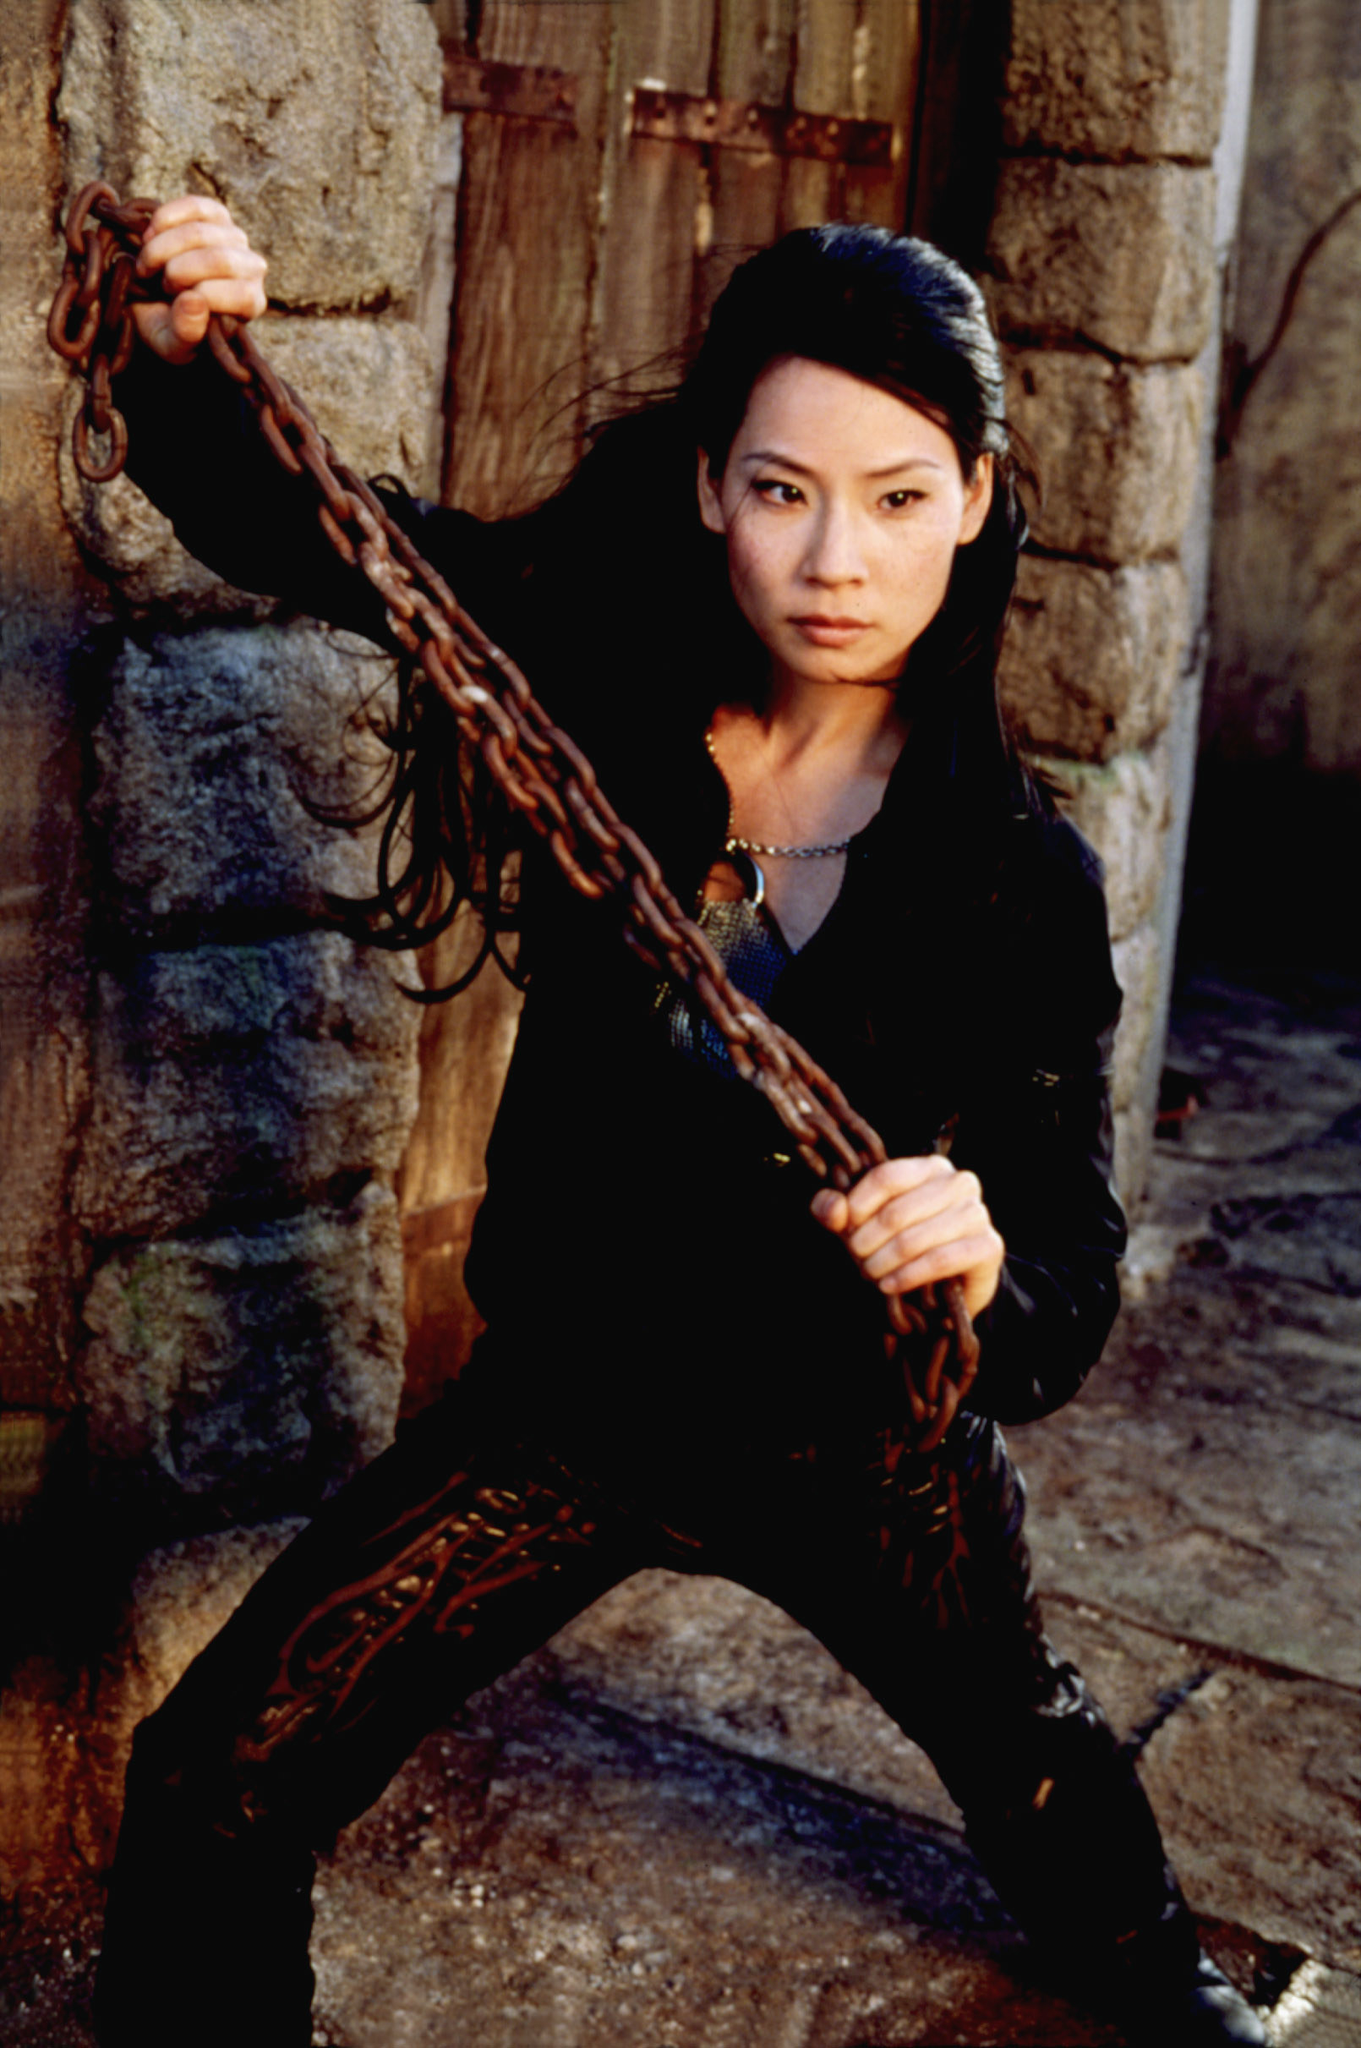How might this scene play out if it were part of a theatrical performance? If this scene were part of a theatrical performance, it would likely be a dramatic and tense moment. The character would emerge from the shadows, gripping the chain, with a spotlight highlighting her intense expression and stance. The set would be designed to reflect the aged stone walls and wooden door, adding to the historical and foreboding atmosphere. The lighting would be moody, with flickering torches or dim, focused beams enhancing the tension. As she prepares for a confrontation, the sound of distant, ominous music would fill the theater, building suspense. Her movements would be deliberate and powerful, maintaining the audience's focus and anticipation. Dialogue might be sparse, relying heavily on her body language and the ambient sounds to convey the significance of the moment. What roles would lighting and sound play in highlighting this scene? In this theatrical scene, lighting and sound are crucial elements. The lighting would be strategically designed to cast stark shadows, emphasizing the character's determined pose and creating a sense of impending danger. Spotlights might highlight her facial expressions, adding depth to her emotions. Dim, ambient light would cast a gloomy atmosphere over the stone walls and wooden door, enhancing the setting's sense of age and foreboding. Sound effects would include the subtle clinking of the chain, the echo of footsteps on the stone floor, and the creak of the wooden door. Underlying music might be minimalistic yet intense, using deep, resonant tones to build tension. Together, these elements draw the audience into the moment, heightening the drama and setting the tone for the unfolding story. Describe her backstory leading up to this moment in the play. The backstory of this character leading up to this dramatic moment in the play is filled with trials and tribulations. She comes from a lineage of warriors, each trained to protect their homeland from invaders and internal threats. Throughout her youth, she was taught the art of combat, strategy, and resilience. Her family’s legacy carries with it a burden of expectations and honor. Early in her adulthood, a treacherous event led to the downfall of her clan, scattering the remaining members. She has since embarked on a journey of vengeance and redemption, seeking to reclaim her family's honor and reunite the clan. This journey has taken her through various terrains, battles, and alliances, hardening her resolve and honing her skills. Now, as she grips the chain and stands against the stone wall, she confronts an adversary who holds the key to her past and the future of her clan. This moment is a culmination of her years of struggle, training, and a relentless pursuit of justice. 